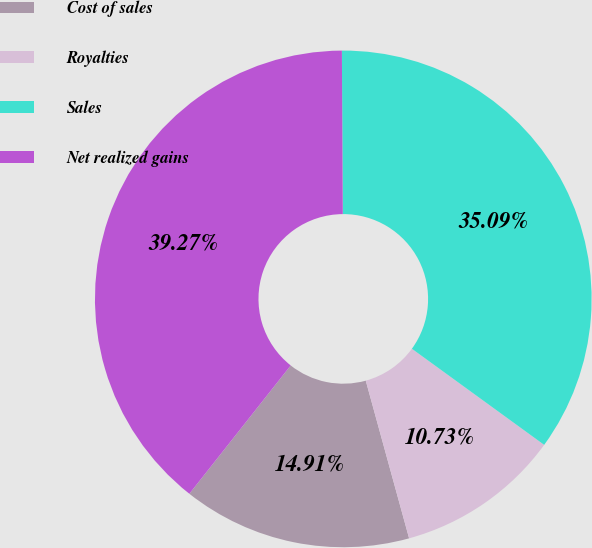Convert chart. <chart><loc_0><loc_0><loc_500><loc_500><pie_chart><fcel>Cost of sales<fcel>Royalties<fcel>Sales<fcel>Net realized gains<nl><fcel>14.91%<fcel>10.73%<fcel>35.09%<fcel>39.27%<nl></chart> 